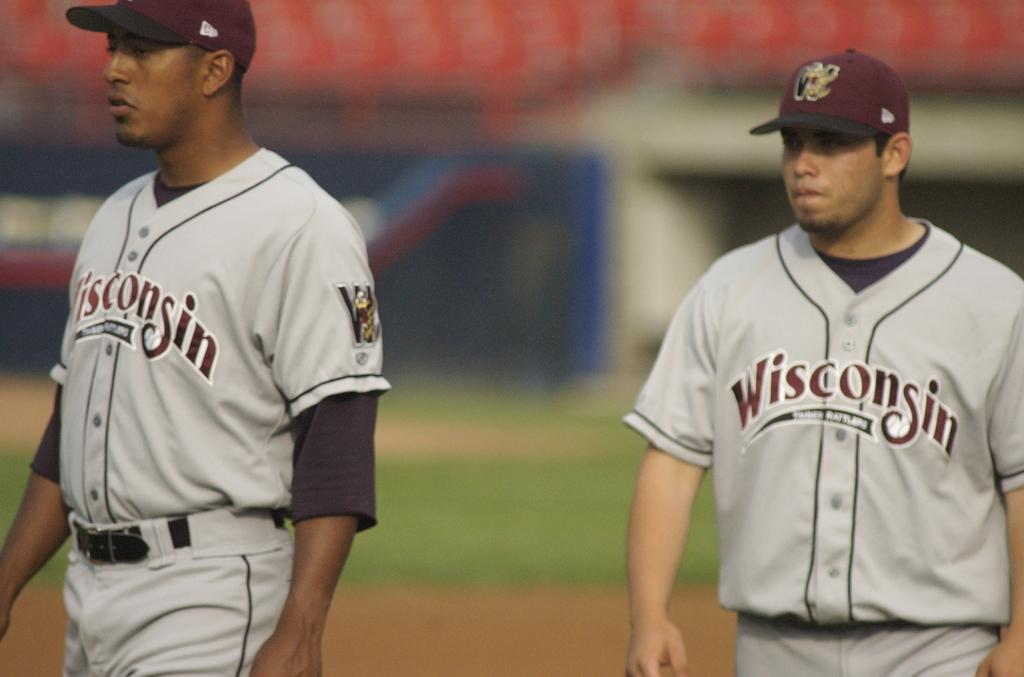<image>
Summarize the visual content of the image. A baseball player is on the field with a jersey with Wisconsin on it. 